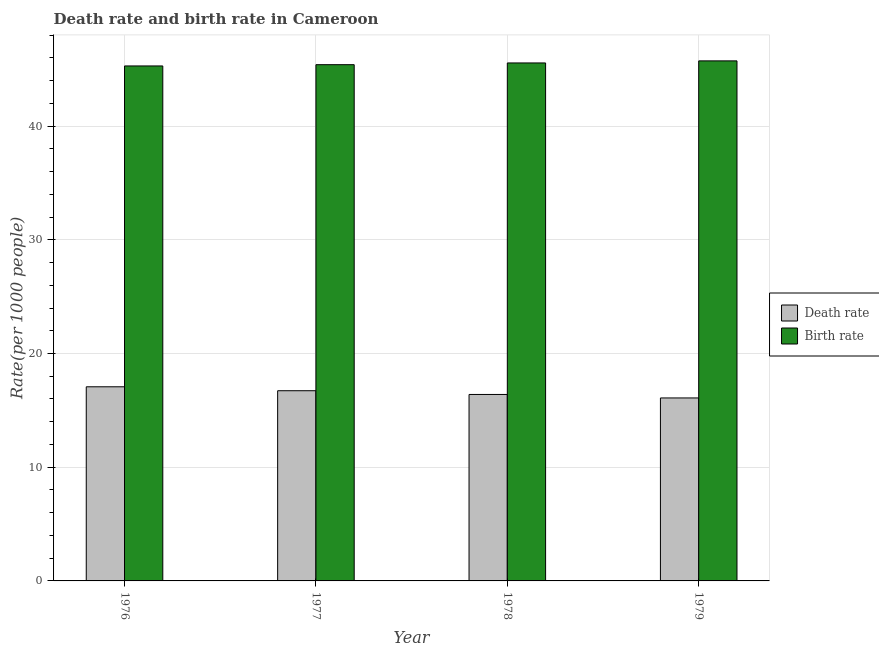How many groups of bars are there?
Offer a very short reply. 4. Are the number of bars per tick equal to the number of legend labels?
Keep it short and to the point. Yes. Are the number of bars on each tick of the X-axis equal?
Your answer should be compact. Yes. How many bars are there on the 2nd tick from the left?
Give a very brief answer. 2. How many bars are there on the 1st tick from the right?
Your answer should be compact. 2. What is the label of the 2nd group of bars from the left?
Keep it short and to the point. 1977. In how many cases, is the number of bars for a given year not equal to the number of legend labels?
Provide a short and direct response. 0. What is the birth rate in 1977?
Make the answer very short. 45.4. Across all years, what is the maximum death rate?
Provide a succinct answer. 17.07. Across all years, what is the minimum death rate?
Offer a terse response. 16.09. In which year was the birth rate maximum?
Ensure brevity in your answer.  1979. In which year was the death rate minimum?
Ensure brevity in your answer.  1979. What is the total death rate in the graph?
Provide a succinct answer. 66.28. What is the difference between the birth rate in 1976 and that in 1978?
Provide a succinct answer. -0.26. What is the difference between the death rate in 1977 and the birth rate in 1976?
Provide a short and direct response. -0.35. What is the average birth rate per year?
Your answer should be compact. 45.49. In the year 1978, what is the difference between the birth rate and death rate?
Make the answer very short. 0. What is the ratio of the death rate in 1977 to that in 1979?
Offer a terse response. 1.04. Is the death rate in 1978 less than that in 1979?
Your answer should be very brief. No. Is the difference between the birth rate in 1976 and 1977 greater than the difference between the death rate in 1976 and 1977?
Keep it short and to the point. No. What is the difference between the highest and the second highest death rate?
Provide a short and direct response. 0.35. What is the difference between the highest and the lowest death rate?
Your response must be concise. 0.98. Is the sum of the birth rate in 1976 and 1978 greater than the maximum death rate across all years?
Ensure brevity in your answer.  Yes. What does the 1st bar from the left in 1979 represents?
Make the answer very short. Death rate. What does the 1st bar from the right in 1978 represents?
Make the answer very short. Birth rate. How many years are there in the graph?
Provide a succinct answer. 4. Are the values on the major ticks of Y-axis written in scientific E-notation?
Your answer should be very brief. No. Does the graph contain grids?
Make the answer very short. Yes. Where does the legend appear in the graph?
Make the answer very short. Center right. How many legend labels are there?
Make the answer very short. 2. How are the legend labels stacked?
Provide a short and direct response. Vertical. What is the title of the graph?
Provide a short and direct response. Death rate and birth rate in Cameroon. What is the label or title of the Y-axis?
Ensure brevity in your answer.  Rate(per 1000 people). What is the Rate(per 1000 people) in Death rate in 1976?
Your answer should be very brief. 17.07. What is the Rate(per 1000 people) of Birth rate in 1976?
Make the answer very short. 45.29. What is the Rate(per 1000 people) in Death rate in 1977?
Provide a succinct answer. 16.73. What is the Rate(per 1000 people) in Birth rate in 1977?
Provide a short and direct response. 45.4. What is the Rate(per 1000 people) in Death rate in 1978?
Provide a succinct answer. 16.4. What is the Rate(per 1000 people) of Birth rate in 1978?
Offer a very short reply. 45.55. What is the Rate(per 1000 people) of Death rate in 1979?
Your answer should be very brief. 16.09. What is the Rate(per 1000 people) of Birth rate in 1979?
Provide a short and direct response. 45.73. Across all years, what is the maximum Rate(per 1000 people) in Death rate?
Your answer should be compact. 17.07. Across all years, what is the maximum Rate(per 1000 people) in Birth rate?
Provide a short and direct response. 45.73. Across all years, what is the minimum Rate(per 1000 people) of Death rate?
Offer a terse response. 16.09. Across all years, what is the minimum Rate(per 1000 people) of Birth rate?
Keep it short and to the point. 45.29. What is the total Rate(per 1000 people) of Death rate in the graph?
Your response must be concise. 66.28. What is the total Rate(per 1000 people) in Birth rate in the graph?
Ensure brevity in your answer.  181.97. What is the difference between the Rate(per 1000 people) in Death rate in 1976 and that in 1977?
Provide a succinct answer. 0.35. What is the difference between the Rate(per 1000 people) of Birth rate in 1976 and that in 1977?
Make the answer very short. -0.11. What is the difference between the Rate(per 1000 people) in Death rate in 1976 and that in 1978?
Your answer should be compact. 0.68. What is the difference between the Rate(per 1000 people) of Birth rate in 1976 and that in 1978?
Provide a succinct answer. -0.26. What is the difference between the Rate(per 1000 people) in Birth rate in 1976 and that in 1979?
Give a very brief answer. -0.45. What is the difference between the Rate(per 1000 people) in Death rate in 1977 and that in 1978?
Your answer should be very brief. 0.33. What is the difference between the Rate(per 1000 people) in Birth rate in 1977 and that in 1978?
Your answer should be compact. -0.15. What is the difference between the Rate(per 1000 people) in Death rate in 1977 and that in 1979?
Offer a terse response. 0.64. What is the difference between the Rate(per 1000 people) in Birth rate in 1977 and that in 1979?
Offer a very short reply. -0.33. What is the difference between the Rate(per 1000 people) of Death rate in 1978 and that in 1979?
Your response must be concise. 0.31. What is the difference between the Rate(per 1000 people) of Birth rate in 1978 and that in 1979?
Your answer should be very brief. -0.18. What is the difference between the Rate(per 1000 people) in Death rate in 1976 and the Rate(per 1000 people) in Birth rate in 1977?
Make the answer very short. -28.33. What is the difference between the Rate(per 1000 people) of Death rate in 1976 and the Rate(per 1000 people) of Birth rate in 1978?
Provide a short and direct response. -28.48. What is the difference between the Rate(per 1000 people) of Death rate in 1976 and the Rate(per 1000 people) of Birth rate in 1979?
Keep it short and to the point. -28.66. What is the difference between the Rate(per 1000 people) in Death rate in 1977 and the Rate(per 1000 people) in Birth rate in 1978?
Keep it short and to the point. -28.82. What is the difference between the Rate(per 1000 people) of Death rate in 1977 and the Rate(per 1000 people) of Birth rate in 1979?
Your response must be concise. -29.01. What is the difference between the Rate(per 1000 people) in Death rate in 1978 and the Rate(per 1000 people) in Birth rate in 1979?
Your response must be concise. -29.34. What is the average Rate(per 1000 people) in Death rate per year?
Your response must be concise. 16.57. What is the average Rate(per 1000 people) in Birth rate per year?
Keep it short and to the point. 45.49. In the year 1976, what is the difference between the Rate(per 1000 people) of Death rate and Rate(per 1000 people) of Birth rate?
Give a very brief answer. -28.21. In the year 1977, what is the difference between the Rate(per 1000 people) in Death rate and Rate(per 1000 people) in Birth rate?
Give a very brief answer. -28.67. In the year 1978, what is the difference between the Rate(per 1000 people) in Death rate and Rate(per 1000 people) in Birth rate?
Your response must be concise. -29.15. In the year 1979, what is the difference between the Rate(per 1000 people) in Death rate and Rate(per 1000 people) in Birth rate?
Make the answer very short. -29.64. What is the ratio of the Rate(per 1000 people) of Death rate in 1976 to that in 1977?
Your response must be concise. 1.02. What is the ratio of the Rate(per 1000 people) of Birth rate in 1976 to that in 1977?
Offer a terse response. 1. What is the ratio of the Rate(per 1000 people) of Death rate in 1976 to that in 1978?
Offer a terse response. 1.04. What is the ratio of the Rate(per 1000 people) in Death rate in 1976 to that in 1979?
Ensure brevity in your answer.  1.06. What is the ratio of the Rate(per 1000 people) in Birth rate in 1976 to that in 1979?
Make the answer very short. 0.99. What is the ratio of the Rate(per 1000 people) of Birth rate in 1977 to that in 1978?
Your answer should be very brief. 1. What is the ratio of the Rate(per 1000 people) in Death rate in 1977 to that in 1979?
Give a very brief answer. 1.04. What is the ratio of the Rate(per 1000 people) in Death rate in 1978 to that in 1979?
Make the answer very short. 1.02. What is the ratio of the Rate(per 1000 people) of Birth rate in 1978 to that in 1979?
Offer a very short reply. 1. What is the difference between the highest and the second highest Rate(per 1000 people) in Death rate?
Keep it short and to the point. 0.35. What is the difference between the highest and the second highest Rate(per 1000 people) in Birth rate?
Your response must be concise. 0.18. What is the difference between the highest and the lowest Rate(per 1000 people) in Death rate?
Ensure brevity in your answer.  0.98. What is the difference between the highest and the lowest Rate(per 1000 people) of Birth rate?
Offer a very short reply. 0.45. 